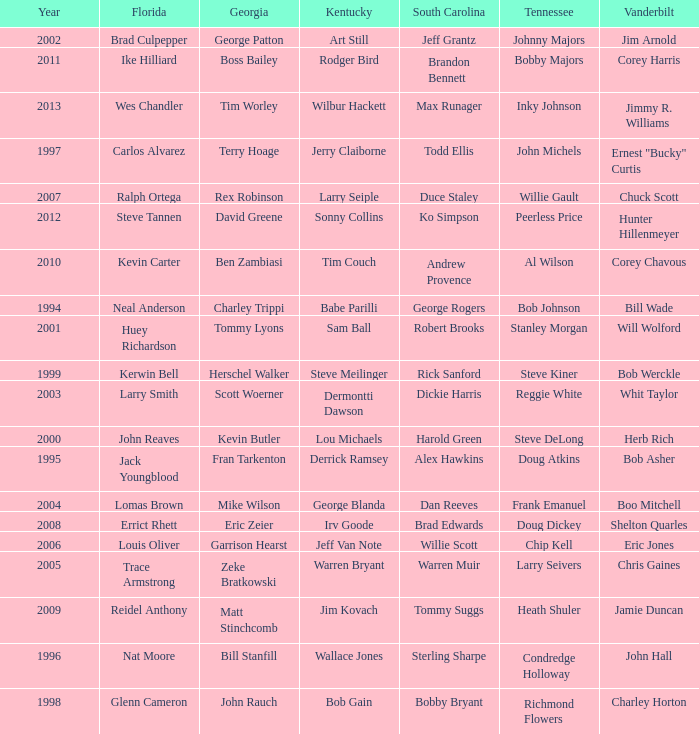I'm looking to parse the entire table for insights. Could you assist me with that? {'header': ['Year', 'Florida', 'Georgia', 'Kentucky', 'South Carolina', 'Tennessee', 'Vanderbilt'], 'rows': [['2002', 'Brad Culpepper', 'George Patton', 'Art Still', 'Jeff Grantz', 'Johnny Majors', 'Jim Arnold'], ['2011', 'Ike Hilliard', 'Boss Bailey', 'Rodger Bird', 'Brandon Bennett', 'Bobby Majors', 'Corey Harris'], ['2013', 'Wes Chandler', 'Tim Worley', 'Wilbur Hackett', 'Max Runager', 'Inky Johnson', 'Jimmy R. Williams'], ['1997', 'Carlos Alvarez', 'Terry Hoage', 'Jerry Claiborne', 'Todd Ellis', 'John Michels', 'Ernest "Bucky" Curtis'], ['2007', 'Ralph Ortega', 'Rex Robinson', 'Larry Seiple', 'Duce Staley', 'Willie Gault', 'Chuck Scott'], ['2012', 'Steve Tannen', 'David Greene', 'Sonny Collins', 'Ko Simpson', 'Peerless Price', 'Hunter Hillenmeyer'], ['2010', 'Kevin Carter', 'Ben Zambiasi', 'Tim Couch', 'Andrew Provence', 'Al Wilson', 'Corey Chavous'], ['1994', 'Neal Anderson', 'Charley Trippi', 'Babe Parilli', 'George Rogers', 'Bob Johnson', 'Bill Wade'], ['2001', 'Huey Richardson', 'Tommy Lyons', 'Sam Ball', 'Robert Brooks', 'Stanley Morgan', 'Will Wolford'], ['1999', 'Kerwin Bell', 'Herschel Walker', 'Steve Meilinger', 'Rick Sanford', 'Steve Kiner', 'Bob Werckle'], ['2003', 'Larry Smith', 'Scott Woerner', 'Dermontti Dawson', 'Dickie Harris', 'Reggie White', 'Whit Taylor'], ['2000', 'John Reaves', 'Kevin Butler', 'Lou Michaels', 'Harold Green', 'Steve DeLong', 'Herb Rich'], ['1995', 'Jack Youngblood', 'Fran Tarkenton', 'Derrick Ramsey', 'Alex Hawkins', 'Doug Atkins', 'Bob Asher'], ['2004', 'Lomas Brown', 'Mike Wilson', 'George Blanda', 'Dan Reeves', 'Frank Emanuel', 'Boo Mitchell'], ['2008', 'Errict Rhett', 'Eric Zeier', 'Irv Goode', 'Brad Edwards', 'Doug Dickey', 'Shelton Quarles'], ['2006', 'Louis Oliver', 'Garrison Hearst', 'Jeff Van Note', 'Willie Scott', 'Chip Kell', 'Eric Jones'], ['2005', 'Trace Armstrong', 'Zeke Bratkowski', 'Warren Bryant', 'Warren Muir', 'Larry Seivers', 'Chris Gaines'], ['2009', 'Reidel Anthony', 'Matt Stinchcomb', 'Jim Kovach', 'Tommy Suggs', 'Heath Shuler', 'Jamie Duncan'], ['1996', 'Nat Moore', 'Bill Stanfill', 'Wallace Jones', 'Sterling Sharpe', 'Condredge Holloway', 'John Hall'], ['1998', 'Glenn Cameron', 'John Rauch', 'Bob Gain', 'Bobby Bryant', 'Richmond Flowers', 'Charley Horton']]} What is the Tennessee that Georgia of kevin butler is in? Steve DeLong. 